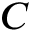<formula> <loc_0><loc_0><loc_500><loc_500>C</formula> 